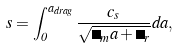Convert formula to latex. <formula><loc_0><loc_0><loc_500><loc_500>s = \int _ { 0 } ^ { a _ { d r a g } } \frac { c _ { s } } { \sqrt { \Omega _ { m } a + \Omega _ { r } } } d a ,</formula> 